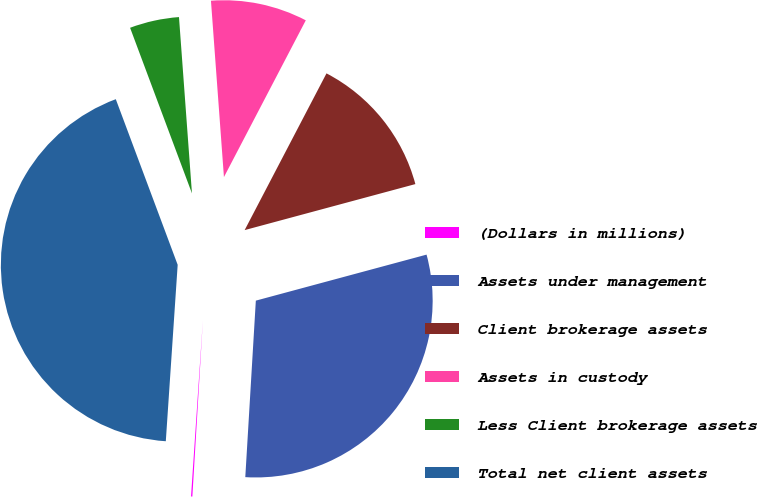Convert chart. <chart><loc_0><loc_0><loc_500><loc_500><pie_chart><fcel>(Dollars in millions)<fcel>Assets under management<fcel>Client brokerage assets<fcel>Assets in custody<fcel>Less Client brokerage assets<fcel>Total net client assets<nl><fcel>0.12%<fcel>30.14%<fcel>13.15%<fcel>8.83%<fcel>4.52%<fcel>43.24%<nl></chart> 